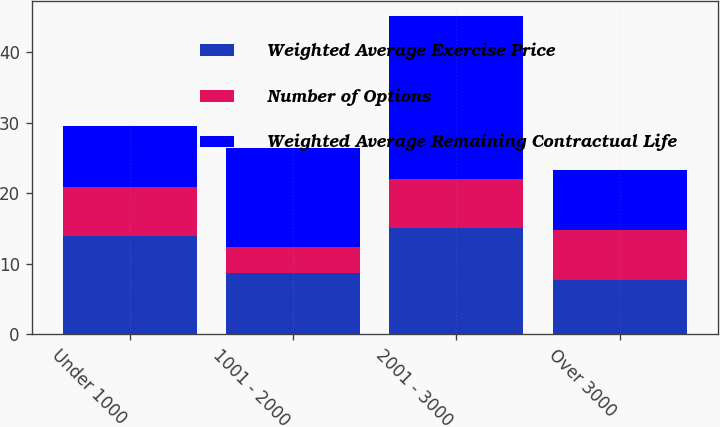Convert chart. <chart><loc_0><loc_0><loc_500><loc_500><stacked_bar_chart><ecel><fcel>Under 1000<fcel>1001 - 2000<fcel>2001 - 3000<fcel>Over 3000<nl><fcel>Weighted Average Exercise Price<fcel>13.9<fcel>8.7<fcel>15<fcel>7.7<nl><fcel>Number of Options<fcel>7<fcel>3.6<fcel>7<fcel>7<nl><fcel>Weighted Average Remaining Contractual Life<fcel>8.65<fcel>14.14<fcel>23.09<fcel>8.65<nl></chart> 